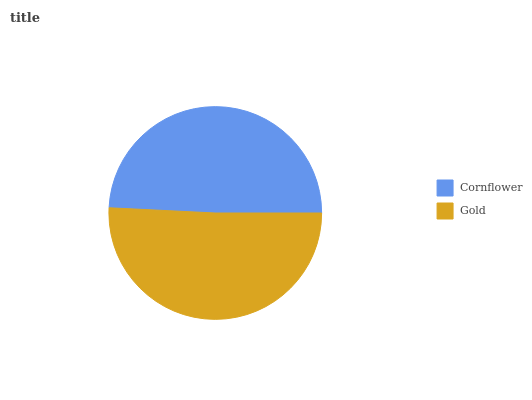Is Cornflower the minimum?
Answer yes or no. Yes. Is Gold the maximum?
Answer yes or no. Yes. Is Gold the minimum?
Answer yes or no. No. Is Gold greater than Cornflower?
Answer yes or no. Yes. Is Cornflower less than Gold?
Answer yes or no. Yes. Is Cornflower greater than Gold?
Answer yes or no. No. Is Gold less than Cornflower?
Answer yes or no. No. Is Gold the high median?
Answer yes or no. Yes. Is Cornflower the low median?
Answer yes or no. Yes. Is Cornflower the high median?
Answer yes or no. No. Is Gold the low median?
Answer yes or no. No. 